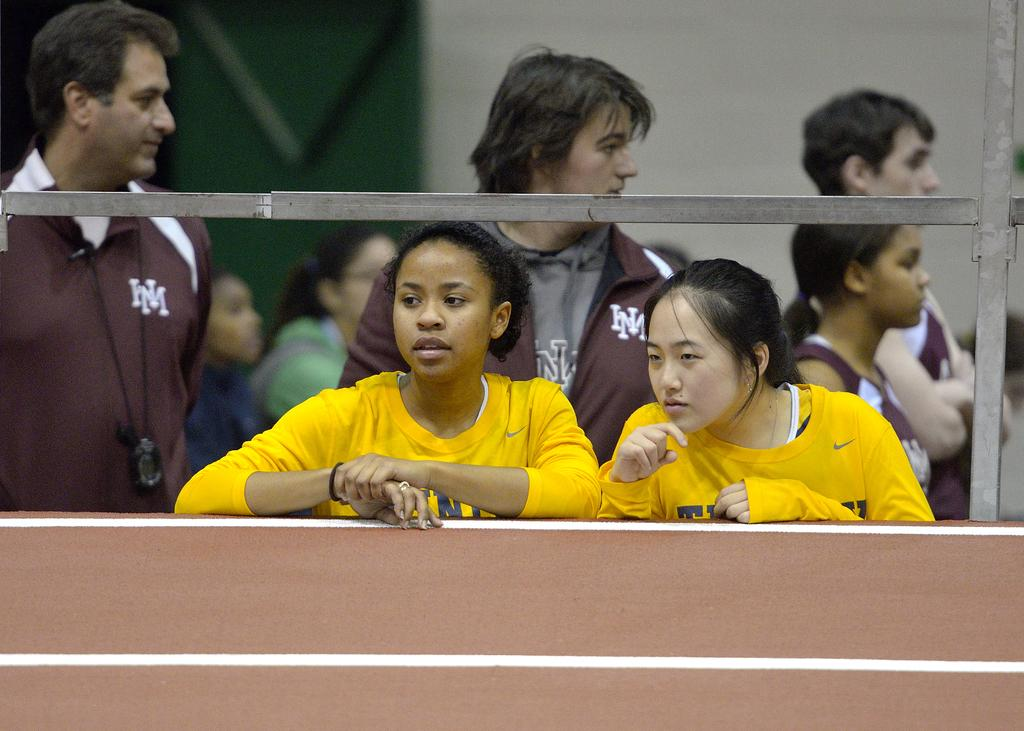What is present on the wall in the image? There are rods attached to the wall in the image. Can you describe the background of the image? There are many people in the background of the image. What type of notebook can be seen on the wall in the image? There is no notebook present on the wall in the image. Is there a library visible in the background of the image? There is no library visible in the background of the image. 